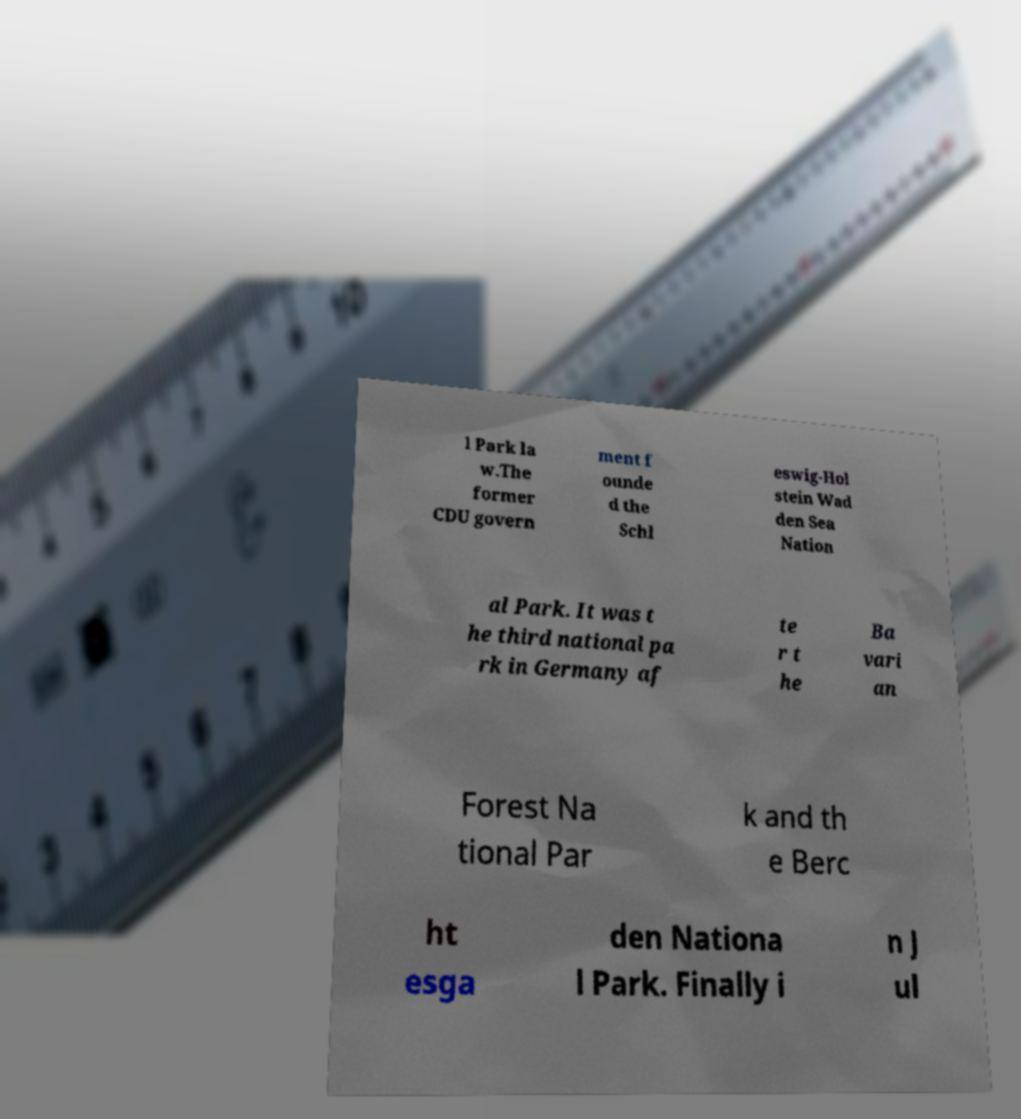Please read and relay the text visible in this image. What does it say? l Park la w.The former CDU govern ment f ounde d the Schl eswig-Hol stein Wad den Sea Nation al Park. It was t he third national pa rk in Germany af te r t he Ba vari an Forest Na tional Par k and th e Berc ht esga den Nationa l Park. Finally i n J ul 